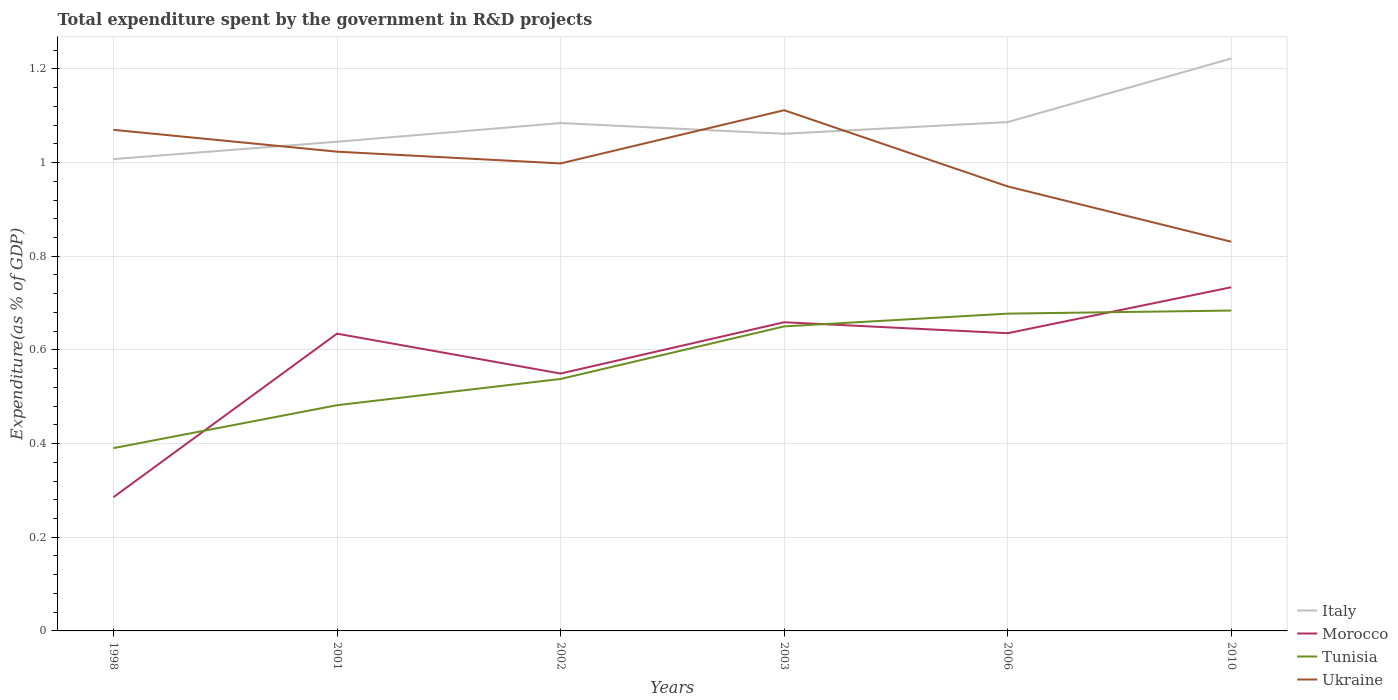How many different coloured lines are there?
Provide a succinct answer. 4. Does the line corresponding to Italy intersect with the line corresponding to Tunisia?
Offer a very short reply. No. Across all years, what is the maximum total expenditure spent by the government in R&D projects in Italy?
Give a very brief answer. 1.01. In which year was the total expenditure spent by the government in R&D projects in Morocco maximum?
Provide a succinct answer. 1998. What is the total total expenditure spent by the government in R&D projects in Italy in the graph?
Your answer should be compact. -0.02. What is the difference between the highest and the second highest total expenditure spent by the government in R&D projects in Italy?
Ensure brevity in your answer.  0.21. What is the difference between the highest and the lowest total expenditure spent by the government in R&D projects in Tunisia?
Your answer should be very brief. 3. How many lines are there?
Your answer should be very brief. 4. What is the difference between two consecutive major ticks on the Y-axis?
Offer a terse response. 0.2. Where does the legend appear in the graph?
Keep it short and to the point. Bottom right. How many legend labels are there?
Your answer should be compact. 4. How are the legend labels stacked?
Provide a short and direct response. Vertical. What is the title of the graph?
Provide a short and direct response. Total expenditure spent by the government in R&D projects. What is the label or title of the Y-axis?
Keep it short and to the point. Expenditure(as % of GDP). What is the Expenditure(as % of GDP) of Italy in 1998?
Give a very brief answer. 1.01. What is the Expenditure(as % of GDP) in Morocco in 1998?
Your response must be concise. 0.29. What is the Expenditure(as % of GDP) in Tunisia in 1998?
Provide a succinct answer. 0.39. What is the Expenditure(as % of GDP) in Ukraine in 1998?
Your answer should be compact. 1.07. What is the Expenditure(as % of GDP) of Italy in 2001?
Offer a terse response. 1.04. What is the Expenditure(as % of GDP) in Morocco in 2001?
Your response must be concise. 0.63. What is the Expenditure(as % of GDP) in Tunisia in 2001?
Provide a succinct answer. 0.48. What is the Expenditure(as % of GDP) of Ukraine in 2001?
Provide a succinct answer. 1.02. What is the Expenditure(as % of GDP) of Italy in 2002?
Give a very brief answer. 1.08. What is the Expenditure(as % of GDP) in Morocco in 2002?
Provide a short and direct response. 0.55. What is the Expenditure(as % of GDP) in Tunisia in 2002?
Your answer should be very brief. 0.54. What is the Expenditure(as % of GDP) of Ukraine in 2002?
Offer a terse response. 1. What is the Expenditure(as % of GDP) in Italy in 2003?
Your response must be concise. 1.06. What is the Expenditure(as % of GDP) in Morocco in 2003?
Give a very brief answer. 0.66. What is the Expenditure(as % of GDP) of Tunisia in 2003?
Ensure brevity in your answer.  0.65. What is the Expenditure(as % of GDP) of Ukraine in 2003?
Your answer should be very brief. 1.11. What is the Expenditure(as % of GDP) in Italy in 2006?
Offer a very short reply. 1.09. What is the Expenditure(as % of GDP) in Morocco in 2006?
Your answer should be compact. 0.64. What is the Expenditure(as % of GDP) in Tunisia in 2006?
Your answer should be compact. 0.68. What is the Expenditure(as % of GDP) of Ukraine in 2006?
Your answer should be compact. 0.95. What is the Expenditure(as % of GDP) in Italy in 2010?
Ensure brevity in your answer.  1.22. What is the Expenditure(as % of GDP) of Morocco in 2010?
Your answer should be compact. 0.73. What is the Expenditure(as % of GDP) of Tunisia in 2010?
Your answer should be very brief. 0.68. What is the Expenditure(as % of GDP) of Ukraine in 2010?
Provide a short and direct response. 0.83. Across all years, what is the maximum Expenditure(as % of GDP) in Italy?
Ensure brevity in your answer.  1.22. Across all years, what is the maximum Expenditure(as % of GDP) of Morocco?
Provide a succinct answer. 0.73. Across all years, what is the maximum Expenditure(as % of GDP) of Tunisia?
Offer a very short reply. 0.68. Across all years, what is the maximum Expenditure(as % of GDP) of Ukraine?
Keep it short and to the point. 1.11. Across all years, what is the minimum Expenditure(as % of GDP) of Italy?
Your answer should be very brief. 1.01. Across all years, what is the minimum Expenditure(as % of GDP) of Morocco?
Make the answer very short. 0.29. Across all years, what is the minimum Expenditure(as % of GDP) of Tunisia?
Your response must be concise. 0.39. Across all years, what is the minimum Expenditure(as % of GDP) of Ukraine?
Ensure brevity in your answer.  0.83. What is the total Expenditure(as % of GDP) in Italy in the graph?
Offer a terse response. 6.51. What is the total Expenditure(as % of GDP) in Morocco in the graph?
Keep it short and to the point. 3.5. What is the total Expenditure(as % of GDP) in Tunisia in the graph?
Offer a terse response. 3.42. What is the total Expenditure(as % of GDP) in Ukraine in the graph?
Your answer should be compact. 5.98. What is the difference between the Expenditure(as % of GDP) of Italy in 1998 and that in 2001?
Provide a short and direct response. -0.04. What is the difference between the Expenditure(as % of GDP) in Morocco in 1998 and that in 2001?
Provide a succinct answer. -0.35. What is the difference between the Expenditure(as % of GDP) in Tunisia in 1998 and that in 2001?
Ensure brevity in your answer.  -0.09. What is the difference between the Expenditure(as % of GDP) in Ukraine in 1998 and that in 2001?
Your response must be concise. 0.05. What is the difference between the Expenditure(as % of GDP) of Italy in 1998 and that in 2002?
Your response must be concise. -0.08. What is the difference between the Expenditure(as % of GDP) in Morocco in 1998 and that in 2002?
Ensure brevity in your answer.  -0.26. What is the difference between the Expenditure(as % of GDP) of Tunisia in 1998 and that in 2002?
Your answer should be compact. -0.15. What is the difference between the Expenditure(as % of GDP) of Ukraine in 1998 and that in 2002?
Give a very brief answer. 0.07. What is the difference between the Expenditure(as % of GDP) of Italy in 1998 and that in 2003?
Keep it short and to the point. -0.05. What is the difference between the Expenditure(as % of GDP) in Morocco in 1998 and that in 2003?
Your answer should be compact. -0.37. What is the difference between the Expenditure(as % of GDP) in Tunisia in 1998 and that in 2003?
Offer a very short reply. -0.26. What is the difference between the Expenditure(as % of GDP) of Ukraine in 1998 and that in 2003?
Your answer should be very brief. -0.04. What is the difference between the Expenditure(as % of GDP) in Italy in 1998 and that in 2006?
Offer a very short reply. -0.08. What is the difference between the Expenditure(as % of GDP) in Morocco in 1998 and that in 2006?
Keep it short and to the point. -0.35. What is the difference between the Expenditure(as % of GDP) of Tunisia in 1998 and that in 2006?
Your answer should be very brief. -0.29. What is the difference between the Expenditure(as % of GDP) of Ukraine in 1998 and that in 2006?
Ensure brevity in your answer.  0.12. What is the difference between the Expenditure(as % of GDP) of Italy in 1998 and that in 2010?
Keep it short and to the point. -0.21. What is the difference between the Expenditure(as % of GDP) in Morocco in 1998 and that in 2010?
Provide a succinct answer. -0.45. What is the difference between the Expenditure(as % of GDP) of Tunisia in 1998 and that in 2010?
Ensure brevity in your answer.  -0.29. What is the difference between the Expenditure(as % of GDP) of Ukraine in 1998 and that in 2010?
Keep it short and to the point. 0.24. What is the difference between the Expenditure(as % of GDP) in Italy in 2001 and that in 2002?
Your response must be concise. -0.04. What is the difference between the Expenditure(as % of GDP) of Morocco in 2001 and that in 2002?
Offer a terse response. 0.09. What is the difference between the Expenditure(as % of GDP) of Tunisia in 2001 and that in 2002?
Keep it short and to the point. -0.06. What is the difference between the Expenditure(as % of GDP) in Ukraine in 2001 and that in 2002?
Your answer should be compact. 0.03. What is the difference between the Expenditure(as % of GDP) in Italy in 2001 and that in 2003?
Give a very brief answer. -0.02. What is the difference between the Expenditure(as % of GDP) in Morocco in 2001 and that in 2003?
Your answer should be very brief. -0.02. What is the difference between the Expenditure(as % of GDP) of Tunisia in 2001 and that in 2003?
Your response must be concise. -0.17. What is the difference between the Expenditure(as % of GDP) in Ukraine in 2001 and that in 2003?
Offer a very short reply. -0.09. What is the difference between the Expenditure(as % of GDP) in Italy in 2001 and that in 2006?
Give a very brief answer. -0.04. What is the difference between the Expenditure(as % of GDP) of Morocco in 2001 and that in 2006?
Your answer should be compact. -0. What is the difference between the Expenditure(as % of GDP) of Tunisia in 2001 and that in 2006?
Your response must be concise. -0.2. What is the difference between the Expenditure(as % of GDP) of Ukraine in 2001 and that in 2006?
Your answer should be compact. 0.07. What is the difference between the Expenditure(as % of GDP) of Italy in 2001 and that in 2010?
Your answer should be very brief. -0.18. What is the difference between the Expenditure(as % of GDP) of Morocco in 2001 and that in 2010?
Your answer should be very brief. -0.1. What is the difference between the Expenditure(as % of GDP) in Tunisia in 2001 and that in 2010?
Ensure brevity in your answer.  -0.2. What is the difference between the Expenditure(as % of GDP) of Ukraine in 2001 and that in 2010?
Ensure brevity in your answer.  0.19. What is the difference between the Expenditure(as % of GDP) of Italy in 2002 and that in 2003?
Make the answer very short. 0.02. What is the difference between the Expenditure(as % of GDP) in Morocco in 2002 and that in 2003?
Offer a terse response. -0.11. What is the difference between the Expenditure(as % of GDP) of Tunisia in 2002 and that in 2003?
Your answer should be very brief. -0.11. What is the difference between the Expenditure(as % of GDP) in Ukraine in 2002 and that in 2003?
Ensure brevity in your answer.  -0.11. What is the difference between the Expenditure(as % of GDP) of Italy in 2002 and that in 2006?
Your answer should be compact. -0. What is the difference between the Expenditure(as % of GDP) in Morocco in 2002 and that in 2006?
Make the answer very short. -0.09. What is the difference between the Expenditure(as % of GDP) in Tunisia in 2002 and that in 2006?
Make the answer very short. -0.14. What is the difference between the Expenditure(as % of GDP) in Ukraine in 2002 and that in 2006?
Provide a short and direct response. 0.05. What is the difference between the Expenditure(as % of GDP) in Italy in 2002 and that in 2010?
Your response must be concise. -0.14. What is the difference between the Expenditure(as % of GDP) of Morocco in 2002 and that in 2010?
Your answer should be compact. -0.18. What is the difference between the Expenditure(as % of GDP) of Tunisia in 2002 and that in 2010?
Give a very brief answer. -0.15. What is the difference between the Expenditure(as % of GDP) of Ukraine in 2002 and that in 2010?
Your answer should be very brief. 0.17. What is the difference between the Expenditure(as % of GDP) of Italy in 2003 and that in 2006?
Provide a short and direct response. -0.02. What is the difference between the Expenditure(as % of GDP) of Morocco in 2003 and that in 2006?
Ensure brevity in your answer.  0.02. What is the difference between the Expenditure(as % of GDP) in Tunisia in 2003 and that in 2006?
Ensure brevity in your answer.  -0.03. What is the difference between the Expenditure(as % of GDP) of Ukraine in 2003 and that in 2006?
Provide a short and direct response. 0.16. What is the difference between the Expenditure(as % of GDP) in Italy in 2003 and that in 2010?
Ensure brevity in your answer.  -0.16. What is the difference between the Expenditure(as % of GDP) in Morocco in 2003 and that in 2010?
Ensure brevity in your answer.  -0.07. What is the difference between the Expenditure(as % of GDP) in Tunisia in 2003 and that in 2010?
Provide a succinct answer. -0.03. What is the difference between the Expenditure(as % of GDP) in Ukraine in 2003 and that in 2010?
Provide a succinct answer. 0.28. What is the difference between the Expenditure(as % of GDP) of Italy in 2006 and that in 2010?
Give a very brief answer. -0.14. What is the difference between the Expenditure(as % of GDP) of Morocco in 2006 and that in 2010?
Offer a very short reply. -0.1. What is the difference between the Expenditure(as % of GDP) of Tunisia in 2006 and that in 2010?
Make the answer very short. -0.01. What is the difference between the Expenditure(as % of GDP) in Ukraine in 2006 and that in 2010?
Make the answer very short. 0.12. What is the difference between the Expenditure(as % of GDP) of Italy in 1998 and the Expenditure(as % of GDP) of Morocco in 2001?
Make the answer very short. 0.37. What is the difference between the Expenditure(as % of GDP) of Italy in 1998 and the Expenditure(as % of GDP) of Tunisia in 2001?
Offer a very short reply. 0.53. What is the difference between the Expenditure(as % of GDP) in Italy in 1998 and the Expenditure(as % of GDP) in Ukraine in 2001?
Ensure brevity in your answer.  -0.02. What is the difference between the Expenditure(as % of GDP) in Morocco in 1998 and the Expenditure(as % of GDP) in Tunisia in 2001?
Ensure brevity in your answer.  -0.2. What is the difference between the Expenditure(as % of GDP) in Morocco in 1998 and the Expenditure(as % of GDP) in Ukraine in 2001?
Make the answer very short. -0.74. What is the difference between the Expenditure(as % of GDP) in Tunisia in 1998 and the Expenditure(as % of GDP) in Ukraine in 2001?
Your answer should be very brief. -0.63. What is the difference between the Expenditure(as % of GDP) of Italy in 1998 and the Expenditure(as % of GDP) of Morocco in 2002?
Provide a succinct answer. 0.46. What is the difference between the Expenditure(as % of GDP) in Italy in 1998 and the Expenditure(as % of GDP) in Tunisia in 2002?
Provide a short and direct response. 0.47. What is the difference between the Expenditure(as % of GDP) in Italy in 1998 and the Expenditure(as % of GDP) in Ukraine in 2002?
Ensure brevity in your answer.  0.01. What is the difference between the Expenditure(as % of GDP) in Morocco in 1998 and the Expenditure(as % of GDP) in Tunisia in 2002?
Make the answer very short. -0.25. What is the difference between the Expenditure(as % of GDP) in Morocco in 1998 and the Expenditure(as % of GDP) in Ukraine in 2002?
Provide a short and direct response. -0.71. What is the difference between the Expenditure(as % of GDP) of Tunisia in 1998 and the Expenditure(as % of GDP) of Ukraine in 2002?
Make the answer very short. -0.61. What is the difference between the Expenditure(as % of GDP) of Italy in 1998 and the Expenditure(as % of GDP) of Morocco in 2003?
Offer a very short reply. 0.35. What is the difference between the Expenditure(as % of GDP) of Italy in 1998 and the Expenditure(as % of GDP) of Tunisia in 2003?
Ensure brevity in your answer.  0.36. What is the difference between the Expenditure(as % of GDP) in Italy in 1998 and the Expenditure(as % of GDP) in Ukraine in 2003?
Keep it short and to the point. -0.1. What is the difference between the Expenditure(as % of GDP) in Morocco in 1998 and the Expenditure(as % of GDP) in Tunisia in 2003?
Give a very brief answer. -0.36. What is the difference between the Expenditure(as % of GDP) in Morocco in 1998 and the Expenditure(as % of GDP) in Ukraine in 2003?
Your answer should be compact. -0.83. What is the difference between the Expenditure(as % of GDP) of Tunisia in 1998 and the Expenditure(as % of GDP) of Ukraine in 2003?
Give a very brief answer. -0.72. What is the difference between the Expenditure(as % of GDP) in Italy in 1998 and the Expenditure(as % of GDP) in Morocco in 2006?
Keep it short and to the point. 0.37. What is the difference between the Expenditure(as % of GDP) of Italy in 1998 and the Expenditure(as % of GDP) of Tunisia in 2006?
Keep it short and to the point. 0.33. What is the difference between the Expenditure(as % of GDP) in Italy in 1998 and the Expenditure(as % of GDP) in Ukraine in 2006?
Ensure brevity in your answer.  0.06. What is the difference between the Expenditure(as % of GDP) of Morocco in 1998 and the Expenditure(as % of GDP) of Tunisia in 2006?
Your answer should be very brief. -0.39. What is the difference between the Expenditure(as % of GDP) of Morocco in 1998 and the Expenditure(as % of GDP) of Ukraine in 2006?
Your response must be concise. -0.66. What is the difference between the Expenditure(as % of GDP) in Tunisia in 1998 and the Expenditure(as % of GDP) in Ukraine in 2006?
Offer a terse response. -0.56. What is the difference between the Expenditure(as % of GDP) of Italy in 1998 and the Expenditure(as % of GDP) of Morocco in 2010?
Offer a very short reply. 0.27. What is the difference between the Expenditure(as % of GDP) of Italy in 1998 and the Expenditure(as % of GDP) of Tunisia in 2010?
Your answer should be very brief. 0.32. What is the difference between the Expenditure(as % of GDP) in Italy in 1998 and the Expenditure(as % of GDP) in Ukraine in 2010?
Your answer should be compact. 0.18. What is the difference between the Expenditure(as % of GDP) of Morocco in 1998 and the Expenditure(as % of GDP) of Tunisia in 2010?
Keep it short and to the point. -0.4. What is the difference between the Expenditure(as % of GDP) in Morocco in 1998 and the Expenditure(as % of GDP) in Ukraine in 2010?
Provide a succinct answer. -0.55. What is the difference between the Expenditure(as % of GDP) in Tunisia in 1998 and the Expenditure(as % of GDP) in Ukraine in 2010?
Give a very brief answer. -0.44. What is the difference between the Expenditure(as % of GDP) of Italy in 2001 and the Expenditure(as % of GDP) of Morocco in 2002?
Give a very brief answer. 0.49. What is the difference between the Expenditure(as % of GDP) of Italy in 2001 and the Expenditure(as % of GDP) of Tunisia in 2002?
Make the answer very short. 0.51. What is the difference between the Expenditure(as % of GDP) in Italy in 2001 and the Expenditure(as % of GDP) in Ukraine in 2002?
Your answer should be very brief. 0.05. What is the difference between the Expenditure(as % of GDP) of Morocco in 2001 and the Expenditure(as % of GDP) of Tunisia in 2002?
Your answer should be very brief. 0.1. What is the difference between the Expenditure(as % of GDP) of Morocco in 2001 and the Expenditure(as % of GDP) of Ukraine in 2002?
Provide a short and direct response. -0.36. What is the difference between the Expenditure(as % of GDP) of Tunisia in 2001 and the Expenditure(as % of GDP) of Ukraine in 2002?
Keep it short and to the point. -0.52. What is the difference between the Expenditure(as % of GDP) in Italy in 2001 and the Expenditure(as % of GDP) in Morocco in 2003?
Provide a succinct answer. 0.39. What is the difference between the Expenditure(as % of GDP) in Italy in 2001 and the Expenditure(as % of GDP) in Tunisia in 2003?
Your answer should be very brief. 0.39. What is the difference between the Expenditure(as % of GDP) in Italy in 2001 and the Expenditure(as % of GDP) in Ukraine in 2003?
Offer a very short reply. -0.07. What is the difference between the Expenditure(as % of GDP) in Morocco in 2001 and the Expenditure(as % of GDP) in Tunisia in 2003?
Provide a short and direct response. -0.02. What is the difference between the Expenditure(as % of GDP) in Morocco in 2001 and the Expenditure(as % of GDP) in Ukraine in 2003?
Your answer should be compact. -0.48. What is the difference between the Expenditure(as % of GDP) in Tunisia in 2001 and the Expenditure(as % of GDP) in Ukraine in 2003?
Offer a very short reply. -0.63. What is the difference between the Expenditure(as % of GDP) in Italy in 2001 and the Expenditure(as % of GDP) in Morocco in 2006?
Offer a terse response. 0.41. What is the difference between the Expenditure(as % of GDP) in Italy in 2001 and the Expenditure(as % of GDP) in Tunisia in 2006?
Offer a very short reply. 0.37. What is the difference between the Expenditure(as % of GDP) in Italy in 2001 and the Expenditure(as % of GDP) in Ukraine in 2006?
Provide a succinct answer. 0.1. What is the difference between the Expenditure(as % of GDP) in Morocco in 2001 and the Expenditure(as % of GDP) in Tunisia in 2006?
Provide a short and direct response. -0.04. What is the difference between the Expenditure(as % of GDP) in Morocco in 2001 and the Expenditure(as % of GDP) in Ukraine in 2006?
Your response must be concise. -0.31. What is the difference between the Expenditure(as % of GDP) in Tunisia in 2001 and the Expenditure(as % of GDP) in Ukraine in 2006?
Make the answer very short. -0.47. What is the difference between the Expenditure(as % of GDP) of Italy in 2001 and the Expenditure(as % of GDP) of Morocco in 2010?
Offer a very short reply. 0.31. What is the difference between the Expenditure(as % of GDP) in Italy in 2001 and the Expenditure(as % of GDP) in Tunisia in 2010?
Make the answer very short. 0.36. What is the difference between the Expenditure(as % of GDP) of Italy in 2001 and the Expenditure(as % of GDP) of Ukraine in 2010?
Make the answer very short. 0.21. What is the difference between the Expenditure(as % of GDP) of Morocco in 2001 and the Expenditure(as % of GDP) of Tunisia in 2010?
Keep it short and to the point. -0.05. What is the difference between the Expenditure(as % of GDP) of Morocco in 2001 and the Expenditure(as % of GDP) of Ukraine in 2010?
Offer a terse response. -0.2. What is the difference between the Expenditure(as % of GDP) of Tunisia in 2001 and the Expenditure(as % of GDP) of Ukraine in 2010?
Provide a succinct answer. -0.35. What is the difference between the Expenditure(as % of GDP) of Italy in 2002 and the Expenditure(as % of GDP) of Morocco in 2003?
Provide a short and direct response. 0.43. What is the difference between the Expenditure(as % of GDP) of Italy in 2002 and the Expenditure(as % of GDP) of Tunisia in 2003?
Offer a very short reply. 0.43. What is the difference between the Expenditure(as % of GDP) in Italy in 2002 and the Expenditure(as % of GDP) in Ukraine in 2003?
Provide a succinct answer. -0.03. What is the difference between the Expenditure(as % of GDP) in Morocco in 2002 and the Expenditure(as % of GDP) in Tunisia in 2003?
Give a very brief answer. -0.1. What is the difference between the Expenditure(as % of GDP) of Morocco in 2002 and the Expenditure(as % of GDP) of Ukraine in 2003?
Your response must be concise. -0.56. What is the difference between the Expenditure(as % of GDP) in Tunisia in 2002 and the Expenditure(as % of GDP) in Ukraine in 2003?
Provide a succinct answer. -0.57. What is the difference between the Expenditure(as % of GDP) of Italy in 2002 and the Expenditure(as % of GDP) of Morocco in 2006?
Your answer should be compact. 0.45. What is the difference between the Expenditure(as % of GDP) in Italy in 2002 and the Expenditure(as % of GDP) in Tunisia in 2006?
Provide a short and direct response. 0.41. What is the difference between the Expenditure(as % of GDP) in Italy in 2002 and the Expenditure(as % of GDP) in Ukraine in 2006?
Ensure brevity in your answer.  0.14. What is the difference between the Expenditure(as % of GDP) of Morocco in 2002 and the Expenditure(as % of GDP) of Tunisia in 2006?
Your answer should be very brief. -0.13. What is the difference between the Expenditure(as % of GDP) in Morocco in 2002 and the Expenditure(as % of GDP) in Ukraine in 2006?
Give a very brief answer. -0.4. What is the difference between the Expenditure(as % of GDP) in Tunisia in 2002 and the Expenditure(as % of GDP) in Ukraine in 2006?
Make the answer very short. -0.41. What is the difference between the Expenditure(as % of GDP) of Italy in 2002 and the Expenditure(as % of GDP) of Morocco in 2010?
Your answer should be compact. 0.35. What is the difference between the Expenditure(as % of GDP) of Italy in 2002 and the Expenditure(as % of GDP) of Tunisia in 2010?
Offer a terse response. 0.4. What is the difference between the Expenditure(as % of GDP) of Italy in 2002 and the Expenditure(as % of GDP) of Ukraine in 2010?
Provide a succinct answer. 0.25. What is the difference between the Expenditure(as % of GDP) in Morocco in 2002 and the Expenditure(as % of GDP) in Tunisia in 2010?
Offer a terse response. -0.13. What is the difference between the Expenditure(as % of GDP) in Morocco in 2002 and the Expenditure(as % of GDP) in Ukraine in 2010?
Provide a succinct answer. -0.28. What is the difference between the Expenditure(as % of GDP) in Tunisia in 2002 and the Expenditure(as % of GDP) in Ukraine in 2010?
Keep it short and to the point. -0.29. What is the difference between the Expenditure(as % of GDP) of Italy in 2003 and the Expenditure(as % of GDP) of Morocco in 2006?
Your response must be concise. 0.43. What is the difference between the Expenditure(as % of GDP) of Italy in 2003 and the Expenditure(as % of GDP) of Tunisia in 2006?
Your answer should be compact. 0.38. What is the difference between the Expenditure(as % of GDP) in Italy in 2003 and the Expenditure(as % of GDP) in Ukraine in 2006?
Ensure brevity in your answer.  0.11. What is the difference between the Expenditure(as % of GDP) in Morocco in 2003 and the Expenditure(as % of GDP) in Tunisia in 2006?
Offer a very short reply. -0.02. What is the difference between the Expenditure(as % of GDP) in Morocco in 2003 and the Expenditure(as % of GDP) in Ukraine in 2006?
Offer a terse response. -0.29. What is the difference between the Expenditure(as % of GDP) in Tunisia in 2003 and the Expenditure(as % of GDP) in Ukraine in 2006?
Give a very brief answer. -0.3. What is the difference between the Expenditure(as % of GDP) in Italy in 2003 and the Expenditure(as % of GDP) in Morocco in 2010?
Provide a succinct answer. 0.33. What is the difference between the Expenditure(as % of GDP) of Italy in 2003 and the Expenditure(as % of GDP) of Tunisia in 2010?
Your answer should be very brief. 0.38. What is the difference between the Expenditure(as % of GDP) of Italy in 2003 and the Expenditure(as % of GDP) of Ukraine in 2010?
Make the answer very short. 0.23. What is the difference between the Expenditure(as % of GDP) of Morocco in 2003 and the Expenditure(as % of GDP) of Tunisia in 2010?
Provide a succinct answer. -0.03. What is the difference between the Expenditure(as % of GDP) in Morocco in 2003 and the Expenditure(as % of GDP) in Ukraine in 2010?
Ensure brevity in your answer.  -0.17. What is the difference between the Expenditure(as % of GDP) in Tunisia in 2003 and the Expenditure(as % of GDP) in Ukraine in 2010?
Offer a very short reply. -0.18. What is the difference between the Expenditure(as % of GDP) of Italy in 2006 and the Expenditure(as % of GDP) of Morocco in 2010?
Your answer should be compact. 0.35. What is the difference between the Expenditure(as % of GDP) in Italy in 2006 and the Expenditure(as % of GDP) in Tunisia in 2010?
Keep it short and to the point. 0.4. What is the difference between the Expenditure(as % of GDP) of Italy in 2006 and the Expenditure(as % of GDP) of Ukraine in 2010?
Ensure brevity in your answer.  0.26. What is the difference between the Expenditure(as % of GDP) of Morocco in 2006 and the Expenditure(as % of GDP) of Tunisia in 2010?
Your answer should be compact. -0.05. What is the difference between the Expenditure(as % of GDP) in Morocco in 2006 and the Expenditure(as % of GDP) in Ukraine in 2010?
Provide a short and direct response. -0.2. What is the difference between the Expenditure(as % of GDP) in Tunisia in 2006 and the Expenditure(as % of GDP) in Ukraine in 2010?
Your answer should be compact. -0.15. What is the average Expenditure(as % of GDP) in Italy per year?
Your answer should be compact. 1.08. What is the average Expenditure(as % of GDP) in Morocco per year?
Provide a succinct answer. 0.58. What is the average Expenditure(as % of GDP) in Tunisia per year?
Ensure brevity in your answer.  0.57. What is the average Expenditure(as % of GDP) of Ukraine per year?
Provide a succinct answer. 1. In the year 1998, what is the difference between the Expenditure(as % of GDP) of Italy and Expenditure(as % of GDP) of Morocco?
Keep it short and to the point. 0.72. In the year 1998, what is the difference between the Expenditure(as % of GDP) of Italy and Expenditure(as % of GDP) of Tunisia?
Your answer should be compact. 0.62. In the year 1998, what is the difference between the Expenditure(as % of GDP) of Italy and Expenditure(as % of GDP) of Ukraine?
Keep it short and to the point. -0.06. In the year 1998, what is the difference between the Expenditure(as % of GDP) in Morocco and Expenditure(as % of GDP) in Tunisia?
Your response must be concise. -0.1. In the year 1998, what is the difference between the Expenditure(as % of GDP) in Morocco and Expenditure(as % of GDP) in Ukraine?
Give a very brief answer. -0.78. In the year 1998, what is the difference between the Expenditure(as % of GDP) in Tunisia and Expenditure(as % of GDP) in Ukraine?
Provide a short and direct response. -0.68. In the year 2001, what is the difference between the Expenditure(as % of GDP) of Italy and Expenditure(as % of GDP) of Morocco?
Provide a short and direct response. 0.41. In the year 2001, what is the difference between the Expenditure(as % of GDP) of Italy and Expenditure(as % of GDP) of Tunisia?
Keep it short and to the point. 0.56. In the year 2001, what is the difference between the Expenditure(as % of GDP) of Italy and Expenditure(as % of GDP) of Ukraine?
Your answer should be very brief. 0.02. In the year 2001, what is the difference between the Expenditure(as % of GDP) in Morocco and Expenditure(as % of GDP) in Tunisia?
Provide a short and direct response. 0.15. In the year 2001, what is the difference between the Expenditure(as % of GDP) in Morocco and Expenditure(as % of GDP) in Ukraine?
Ensure brevity in your answer.  -0.39. In the year 2001, what is the difference between the Expenditure(as % of GDP) in Tunisia and Expenditure(as % of GDP) in Ukraine?
Give a very brief answer. -0.54. In the year 2002, what is the difference between the Expenditure(as % of GDP) in Italy and Expenditure(as % of GDP) in Morocco?
Your answer should be very brief. 0.53. In the year 2002, what is the difference between the Expenditure(as % of GDP) of Italy and Expenditure(as % of GDP) of Tunisia?
Your answer should be very brief. 0.55. In the year 2002, what is the difference between the Expenditure(as % of GDP) of Italy and Expenditure(as % of GDP) of Ukraine?
Give a very brief answer. 0.09. In the year 2002, what is the difference between the Expenditure(as % of GDP) of Morocco and Expenditure(as % of GDP) of Tunisia?
Your answer should be compact. 0.01. In the year 2002, what is the difference between the Expenditure(as % of GDP) in Morocco and Expenditure(as % of GDP) in Ukraine?
Offer a very short reply. -0.45. In the year 2002, what is the difference between the Expenditure(as % of GDP) of Tunisia and Expenditure(as % of GDP) of Ukraine?
Provide a succinct answer. -0.46. In the year 2003, what is the difference between the Expenditure(as % of GDP) of Italy and Expenditure(as % of GDP) of Morocco?
Provide a short and direct response. 0.4. In the year 2003, what is the difference between the Expenditure(as % of GDP) of Italy and Expenditure(as % of GDP) of Tunisia?
Your response must be concise. 0.41. In the year 2003, what is the difference between the Expenditure(as % of GDP) of Italy and Expenditure(as % of GDP) of Ukraine?
Make the answer very short. -0.05. In the year 2003, what is the difference between the Expenditure(as % of GDP) of Morocco and Expenditure(as % of GDP) of Tunisia?
Make the answer very short. 0.01. In the year 2003, what is the difference between the Expenditure(as % of GDP) of Morocco and Expenditure(as % of GDP) of Ukraine?
Offer a very short reply. -0.45. In the year 2003, what is the difference between the Expenditure(as % of GDP) of Tunisia and Expenditure(as % of GDP) of Ukraine?
Offer a very short reply. -0.46. In the year 2006, what is the difference between the Expenditure(as % of GDP) of Italy and Expenditure(as % of GDP) of Morocco?
Provide a short and direct response. 0.45. In the year 2006, what is the difference between the Expenditure(as % of GDP) of Italy and Expenditure(as % of GDP) of Tunisia?
Offer a terse response. 0.41. In the year 2006, what is the difference between the Expenditure(as % of GDP) in Italy and Expenditure(as % of GDP) in Ukraine?
Keep it short and to the point. 0.14. In the year 2006, what is the difference between the Expenditure(as % of GDP) of Morocco and Expenditure(as % of GDP) of Tunisia?
Your answer should be very brief. -0.04. In the year 2006, what is the difference between the Expenditure(as % of GDP) of Morocco and Expenditure(as % of GDP) of Ukraine?
Offer a terse response. -0.31. In the year 2006, what is the difference between the Expenditure(as % of GDP) of Tunisia and Expenditure(as % of GDP) of Ukraine?
Provide a short and direct response. -0.27. In the year 2010, what is the difference between the Expenditure(as % of GDP) of Italy and Expenditure(as % of GDP) of Morocco?
Offer a very short reply. 0.49. In the year 2010, what is the difference between the Expenditure(as % of GDP) in Italy and Expenditure(as % of GDP) in Tunisia?
Provide a succinct answer. 0.54. In the year 2010, what is the difference between the Expenditure(as % of GDP) of Italy and Expenditure(as % of GDP) of Ukraine?
Provide a succinct answer. 0.39. In the year 2010, what is the difference between the Expenditure(as % of GDP) of Morocco and Expenditure(as % of GDP) of Tunisia?
Provide a short and direct response. 0.05. In the year 2010, what is the difference between the Expenditure(as % of GDP) in Morocco and Expenditure(as % of GDP) in Ukraine?
Your answer should be compact. -0.1. In the year 2010, what is the difference between the Expenditure(as % of GDP) in Tunisia and Expenditure(as % of GDP) in Ukraine?
Keep it short and to the point. -0.15. What is the ratio of the Expenditure(as % of GDP) in Italy in 1998 to that in 2001?
Provide a succinct answer. 0.96. What is the ratio of the Expenditure(as % of GDP) in Morocco in 1998 to that in 2001?
Provide a succinct answer. 0.45. What is the ratio of the Expenditure(as % of GDP) in Tunisia in 1998 to that in 2001?
Your answer should be very brief. 0.81. What is the ratio of the Expenditure(as % of GDP) in Ukraine in 1998 to that in 2001?
Make the answer very short. 1.05. What is the ratio of the Expenditure(as % of GDP) of Italy in 1998 to that in 2002?
Give a very brief answer. 0.93. What is the ratio of the Expenditure(as % of GDP) of Morocco in 1998 to that in 2002?
Ensure brevity in your answer.  0.52. What is the ratio of the Expenditure(as % of GDP) in Tunisia in 1998 to that in 2002?
Your answer should be compact. 0.73. What is the ratio of the Expenditure(as % of GDP) of Ukraine in 1998 to that in 2002?
Your answer should be very brief. 1.07. What is the ratio of the Expenditure(as % of GDP) in Italy in 1998 to that in 2003?
Your answer should be compact. 0.95. What is the ratio of the Expenditure(as % of GDP) of Morocco in 1998 to that in 2003?
Offer a terse response. 0.43. What is the ratio of the Expenditure(as % of GDP) of Tunisia in 1998 to that in 2003?
Offer a very short reply. 0.6. What is the ratio of the Expenditure(as % of GDP) in Ukraine in 1998 to that in 2003?
Make the answer very short. 0.96. What is the ratio of the Expenditure(as % of GDP) in Italy in 1998 to that in 2006?
Your answer should be very brief. 0.93. What is the ratio of the Expenditure(as % of GDP) in Morocco in 1998 to that in 2006?
Provide a short and direct response. 0.45. What is the ratio of the Expenditure(as % of GDP) in Tunisia in 1998 to that in 2006?
Ensure brevity in your answer.  0.58. What is the ratio of the Expenditure(as % of GDP) of Ukraine in 1998 to that in 2006?
Give a very brief answer. 1.13. What is the ratio of the Expenditure(as % of GDP) of Italy in 1998 to that in 2010?
Offer a terse response. 0.82. What is the ratio of the Expenditure(as % of GDP) in Morocco in 1998 to that in 2010?
Your answer should be very brief. 0.39. What is the ratio of the Expenditure(as % of GDP) of Tunisia in 1998 to that in 2010?
Offer a terse response. 0.57. What is the ratio of the Expenditure(as % of GDP) of Ukraine in 1998 to that in 2010?
Offer a terse response. 1.29. What is the ratio of the Expenditure(as % of GDP) of Italy in 2001 to that in 2002?
Your response must be concise. 0.96. What is the ratio of the Expenditure(as % of GDP) of Morocco in 2001 to that in 2002?
Your response must be concise. 1.16. What is the ratio of the Expenditure(as % of GDP) of Tunisia in 2001 to that in 2002?
Make the answer very short. 0.9. What is the ratio of the Expenditure(as % of GDP) in Ukraine in 2001 to that in 2002?
Your response must be concise. 1.03. What is the ratio of the Expenditure(as % of GDP) in Italy in 2001 to that in 2003?
Offer a very short reply. 0.98. What is the ratio of the Expenditure(as % of GDP) in Tunisia in 2001 to that in 2003?
Ensure brevity in your answer.  0.74. What is the ratio of the Expenditure(as % of GDP) in Ukraine in 2001 to that in 2003?
Ensure brevity in your answer.  0.92. What is the ratio of the Expenditure(as % of GDP) in Italy in 2001 to that in 2006?
Provide a succinct answer. 0.96. What is the ratio of the Expenditure(as % of GDP) in Morocco in 2001 to that in 2006?
Keep it short and to the point. 1. What is the ratio of the Expenditure(as % of GDP) in Tunisia in 2001 to that in 2006?
Keep it short and to the point. 0.71. What is the ratio of the Expenditure(as % of GDP) in Ukraine in 2001 to that in 2006?
Keep it short and to the point. 1.08. What is the ratio of the Expenditure(as % of GDP) in Italy in 2001 to that in 2010?
Your response must be concise. 0.85. What is the ratio of the Expenditure(as % of GDP) of Morocco in 2001 to that in 2010?
Provide a succinct answer. 0.86. What is the ratio of the Expenditure(as % of GDP) in Tunisia in 2001 to that in 2010?
Offer a very short reply. 0.7. What is the ratio of the Expenditure(as % of GDP) in Ukraine in 2001 to that in 2010?
Offer a terse response. 1.23. What is the ratio of the Expenditure(as % of GDP) of Italy in 2002 to that in 2003?
Ensure brevity in your answer.  1.02. What is the ratio of the Expenditure(as % of GDP) of Morocco in 2002 to that in 2003?
Ensure brevity in your answer.  0.83. What is the ratio of the Expenditure(as % of GDP) in Tunisia in 2002 to that in 2003?
Your answer should be very brief. 0.83. What is the ratio of the Expenditure(as % of GDP) in Ukraine in 2002 to that in 2003?
Make the answer very short. 0.9. What is the ratio of the Expenditure(as % of GDP) of Italy in 2002 to that in 2006?
Offer a very short reply. 1. What is the ratio of the Expenditure(as % of GDP) of Morocco in 2002 to that in 2006?
Keep it short and to the point. 0.86. What is the ratio of the Expenditure(as % of GDP) of Tunisia in 2002 to that in 2006?
Give a very brief answer. 0.79. What is the ratio of the Expenditure(as % of GDP) in Ukraine in 2002 to that in 2006?
Ensure brevity in your answer.  1.05. What is the ratio of the Expenditure(as % of GDP) in Italy in 2002 to that in 2010?
Give a very brief answer. 0.89. What is the ratio of the Expenditure(as % of GDP) of Morocco in 2002 to that in 2010?
Provide a succinct answer. 0.75. What is the ratio of the Expenditure(as % of GDP) of Tunisia in 2002 to that in 2010?
Give a very brief answer. 0.79. What is the ratio of the Expenditure(as % of GDP) of Ukraine in 2002 to that in 2010?
Your response must be concise. 1.2. What is the ratio of the Expenditure(as % of GDP) in Italy in 2003 to that in 2006?
Provide a succinct answer. 0.98. What is the ratio of the Expenditure(as % of GDP) of Morocco in 2003 to that in 2006?
Offer a terse response. 1.04. What is the ratio of the Expenditure(as % of GDP) in Tunisia in 2003 to that in 2006?
Ensure brevity in your answer.  0.96. What is the ratio of the Expenditure(as % of GDP) in Ukraine in 2003 to that in 2006?
Provide a short and direct response. 1.17. What is the ratio of the Expenditure(as % of GDP) of Italy in 2003 to that in 2010?
Your response must be concise. 0.87. What is the ratio of the Expenditure(as % of GDP) of Morocco in 2003 to that in 2010?
Offer a terse response. 0.9. What is the ratio of the Expenditure(as % of GDP) of Tunisia in 2003 to that in 2010?
Offer a very short reply. 0.95. What is the ratio of the Expenditure(as % of GDP) in Ukraine in 2003 to that in 2010?
Give a very brief answer. 1.34. What is the ratio of the Expenditure(as % of GDP) in Italy in 2006 to that in 2010?
Offer a very short reply. 0.89. What is the ratio of the Expenditure(as % of GDP) of Morocco in 2006 to that in 2010?
Ensure brevity in your answer.  0.87. What is the ratio of the Expenditure(as % of GDP) of Tunisia in 2006 to that in 2010?
Make the answer very short. 0.99. What is the ratio of the Expenditure(as % of GDP) in Ukraine in 2006 to that in 2010?
Your answer should be compact. 1.14. What is the difference between the highest and the second highest Expenditure(as % of GDP) in Italy?
Make the answer very short. 0.14. What is the difference between the highest and the second highest Expenditure(as % of GDP) in Morocco?
Your answer should be very brief. 0.07. What is the difference between the highest and the second highest Expenditure(as % of GDP) in Tunisia?
Provide a succinct answer. 0.01. What is the difference between the highest and the second highest Expenditure(as % of GDP) in Ukraine?
Offer a terse response. 0.04. What is the difference between the highest and the lowest Expenditure(as % of GDP) of Italy?
Provide a short and direct response. 0.21. What is the difference between the highest and the lowest Expenditure(as % of GDP) in Morocco?
Give a very brief answer. 0.45. What is the difference between the highest and the lowest Expenditure(as % of GDP) in Tunisia?
Give a very brief answer. 0.29. What is the difference between the highest and the lowest Expenditure(as % of GDP) of Ukraine?
Keep it short and to the point. 0.28. 